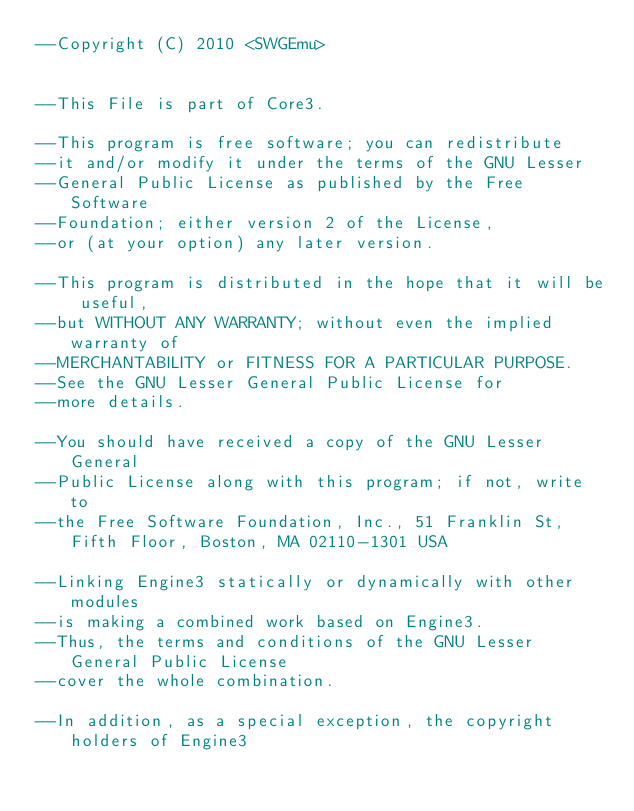Convert code to text. <code><loc_0><loc_0><loc_500><loc_500><_Lua_>--Copyright (C) 2010 <SWGEmu>


--This File is part of Core3.

--This program is free software; you can redistribute 
--it and/or modify it under the terms of the GNU Lesser 
--General Public License as published by the Free Software
--Foundation; either version 2 of the License, 
--or (at your option) any later version.

--This program is distributed in the hope that it will be useful, 
--but WITHOUT ANY WARRANTY; without even the implied warranty of 
--MERCHANTABILITY or FITNESS FOR A PARTICULAR PURPOSE. 
--See the GNU Lesser General Public License for
--more details.

--You should have received a copy of the GNU Lesser General 
--Public License along with this program; if not, write to
--the Free Software Foundation, Inc., 51 Franklin St, Fifth Floor, Boston, MA 02110-1301 USA

--Linking Engine3 statically or dynamically with other modules 
--is making a combined work based on Engine3. 
--Thus, the terms and conditions of the GNU Lesser General Public License 
--cover the whole combination.

--In addition, as a special exception, the copyright holders of Engine3 </code> 